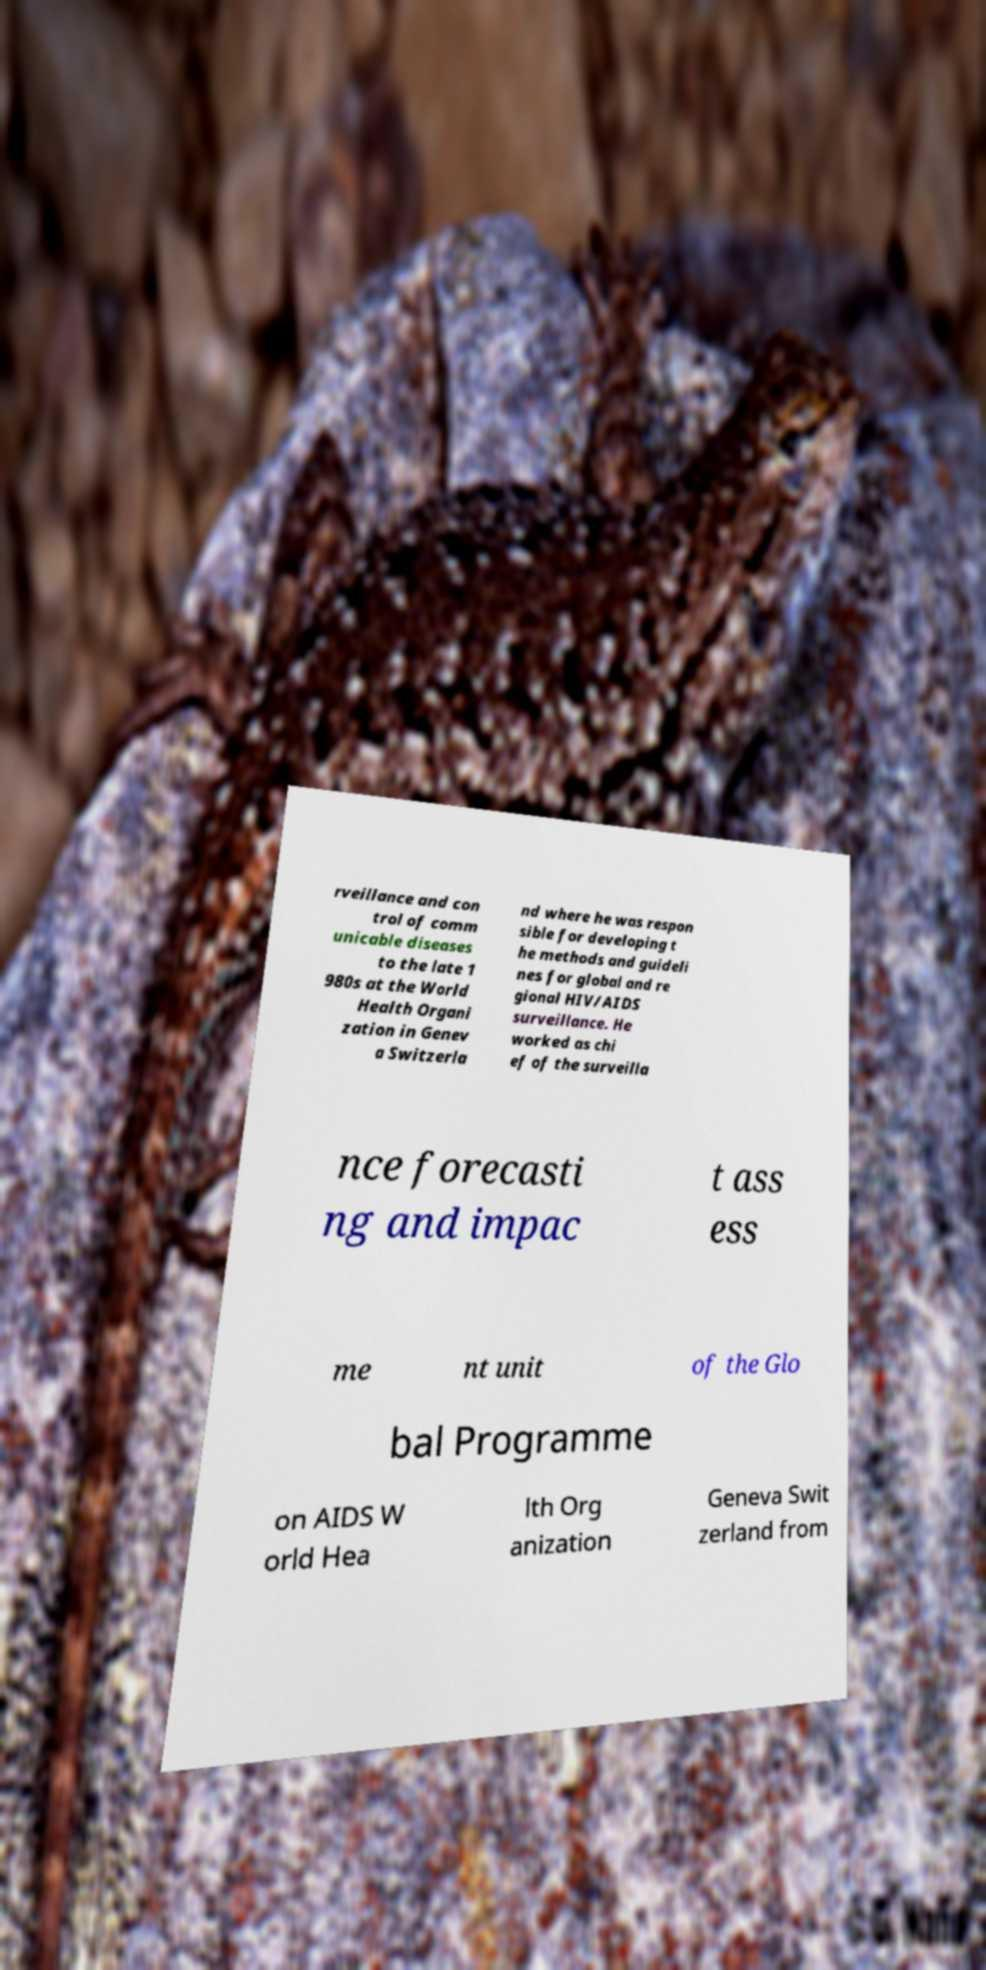Please identify and transcribe the text found in this image. rveillance and con trol of comm unicable diseases to the late 1 980s at the World Health Organi zation in Genev a Switzerla nd where he was respon sible for developing t he methods and guideli nes for global and re gional HIV/AIDS surveillance. He worked as chi ef of the surveilla nce forecasti ng and impac t ass ess me nt unit of the Glo bal Programme on AIDS W orld Hea lth Org anization Geneva Swit zerland from 